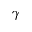Convert formula to latex. <formula><loc_0><loc_0><loc_500><loc_500>\gamma</formula> 